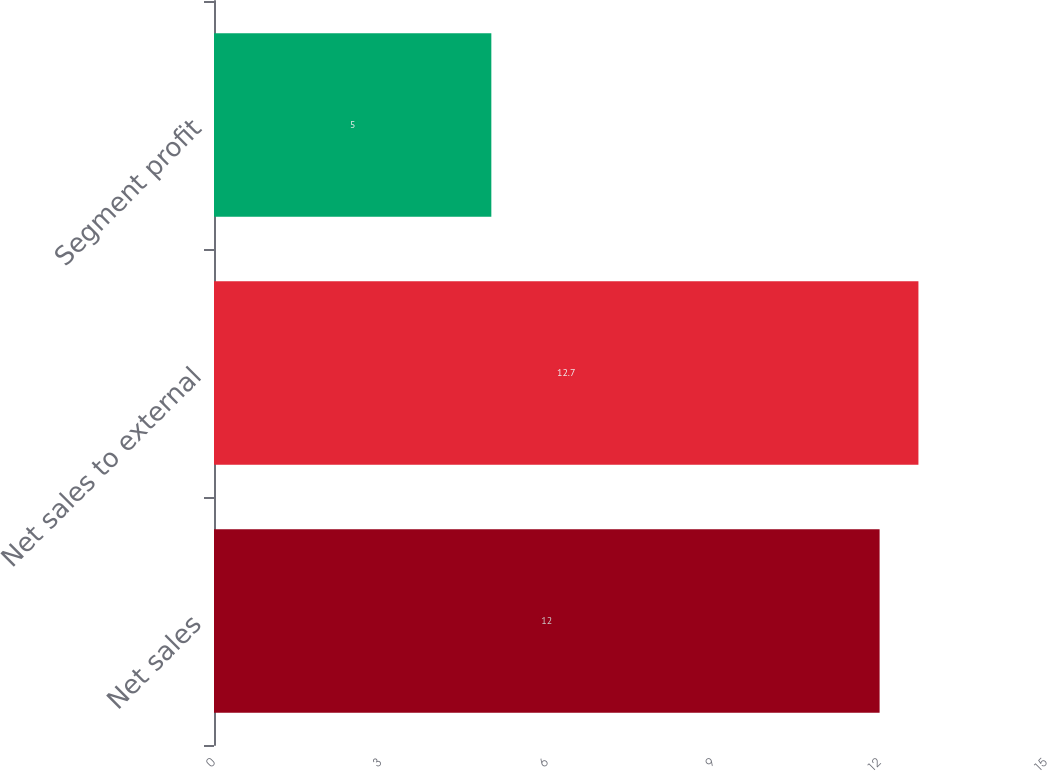Convert chart to OTSL. <chart><loc_0><loc_0><loc_500><loc_500><bar_chart><fcel>Net sales<fcel>Net sales to external<fcel>Segment profit<nl><fcel>12<fcel>12.7<fcel>5<nl></chart> 